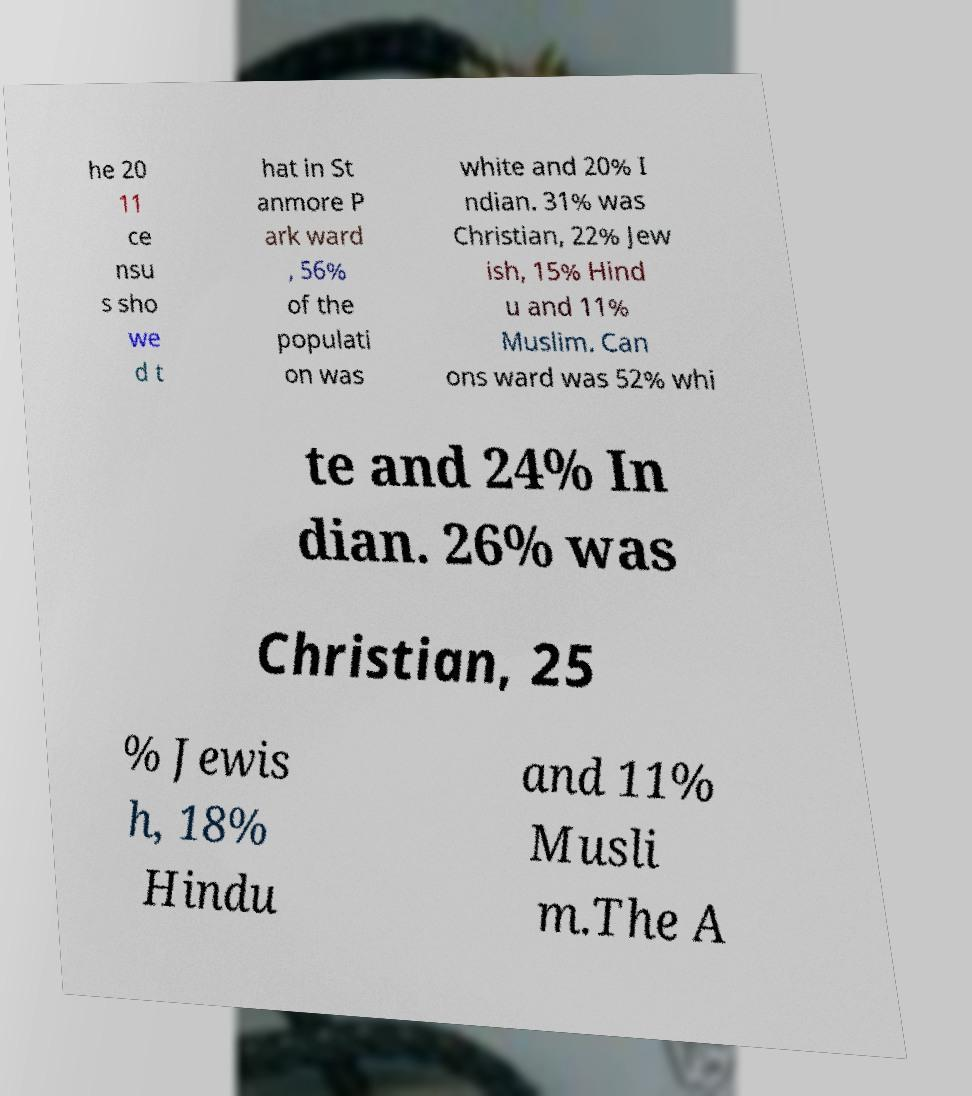Could you extract and type out the text from this image? he 20 11 ce nsu s sho we d t hat in St anmore P ark ward , 56% of the populati on was white and 20% I ndian. 31% was Christian, 22% Jew ish, 15% Hind u and 11% Muslim. Can ons ward was 52% whi te and 24% In dian. 26% was Christian, 25 % Jewis h, 18% Hindu and 11% Musli m.The A 